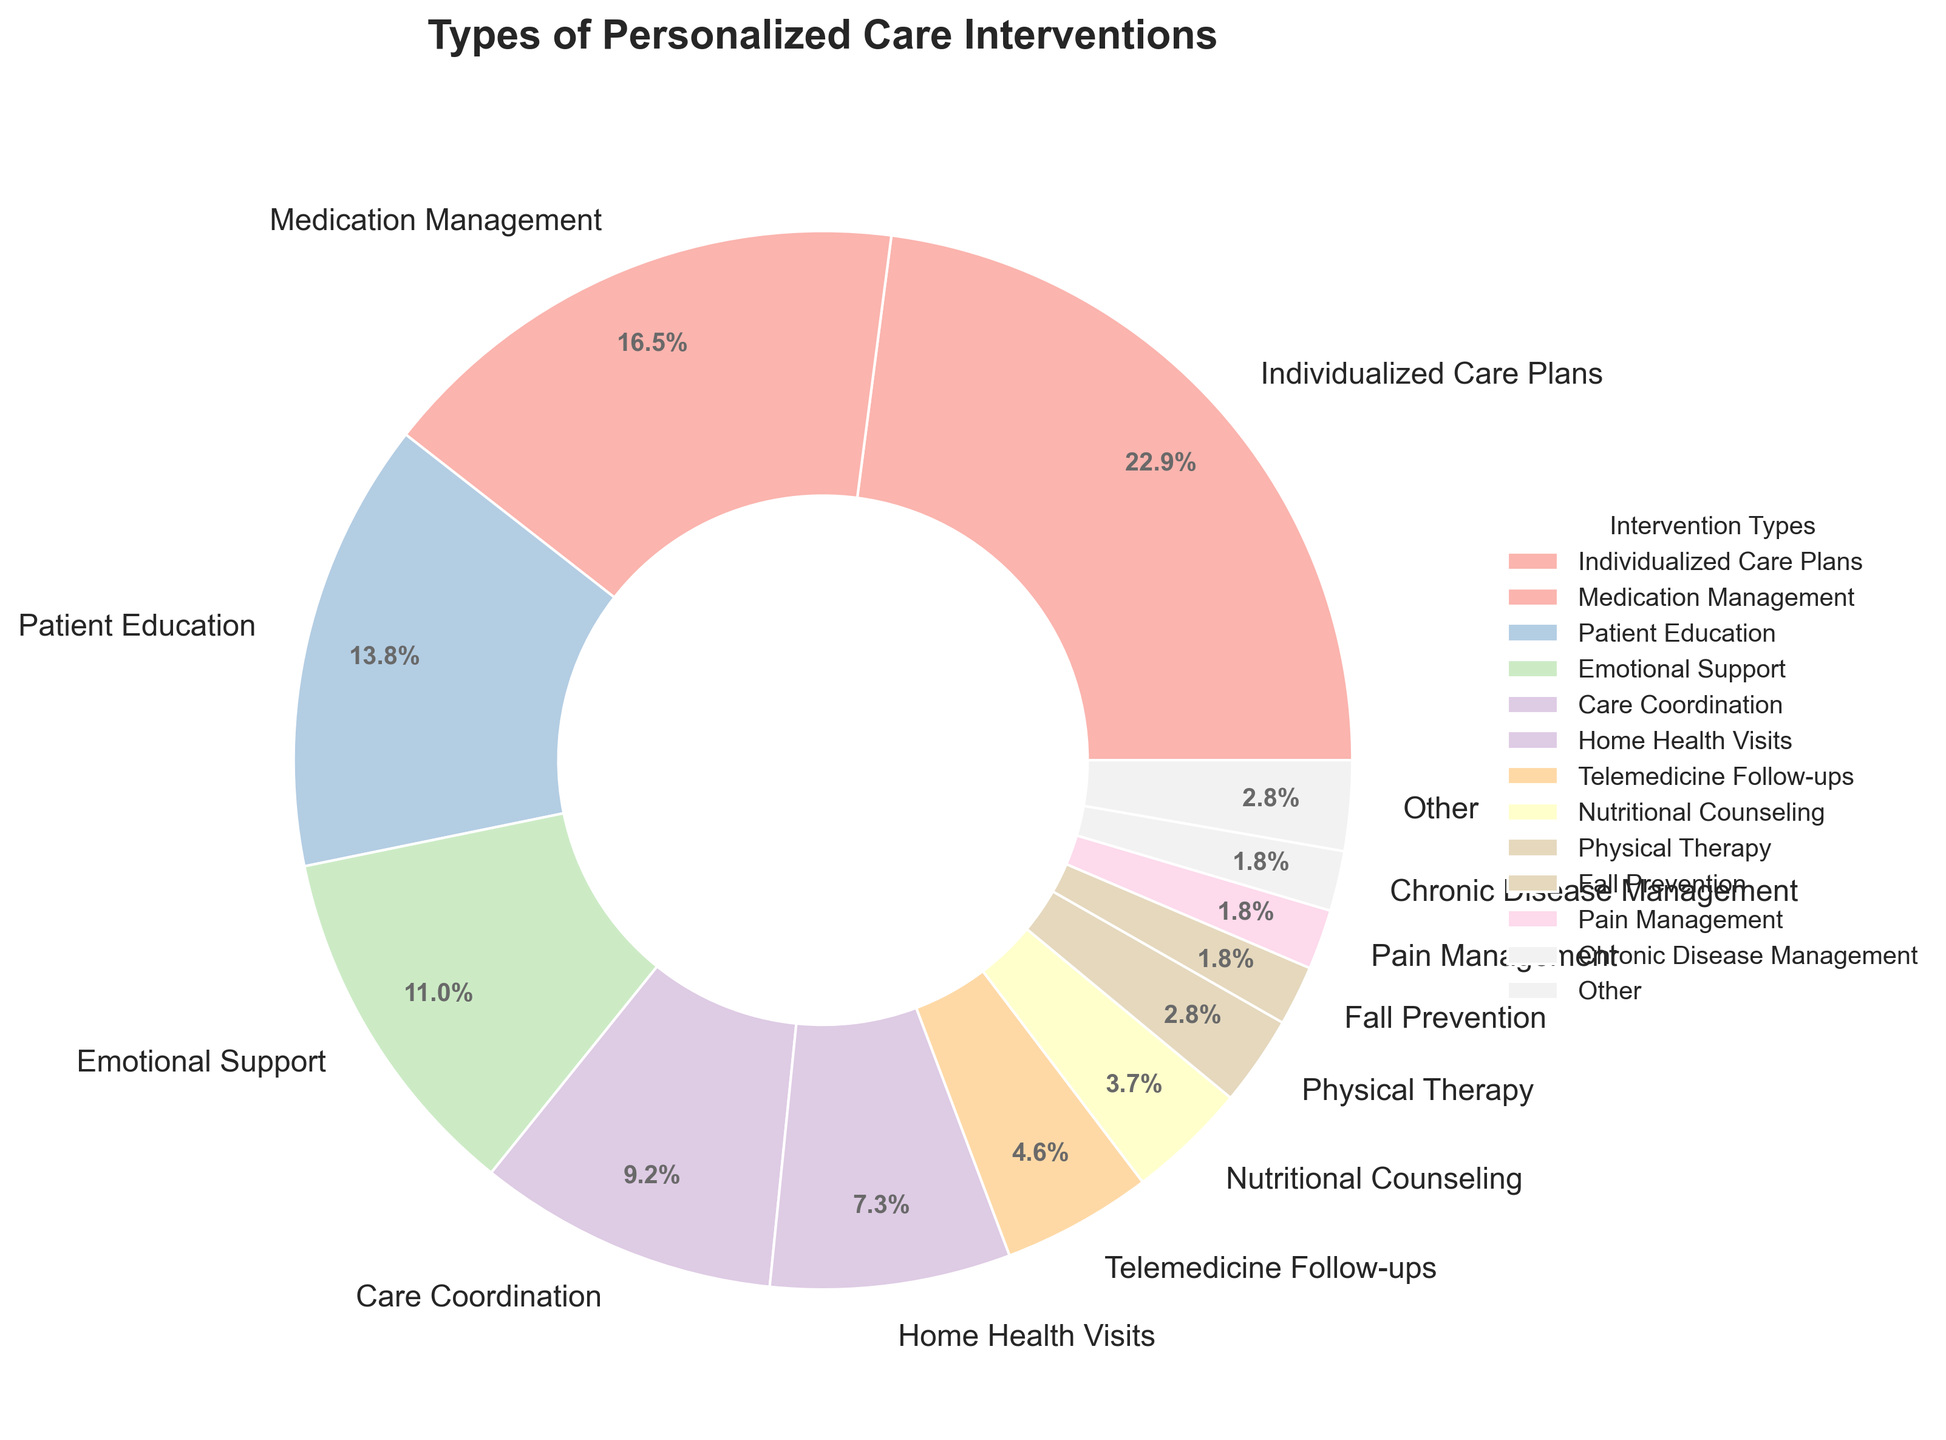What type of personalized care intervention is provided the most? The segment with the largest proportion is visually identifiable based on the chart's sizes and labels. Individualized Care Plans has the largest size representing 25%.
Answer: Individualized Care Plans Which two intervention types are both listed with less than 5%? Observing the size segments and labels in the chart, Telemedicine Follow-ups, and Nutritional Counseling are both listed with less than 5%. Their respective proportions are 5% and 4%.
Answer: Telemedicine Follow-ups and Nutritional Counseling What is the combined percentage of Emotional Support and Care Coordination interventions? The chart shows 12% for Emotional Support and 10% for Care Coordination. Adding these two values: 12% + 10% = 22%.
Answer: 22% Is Pain Management provided more or less than Cognitive Stimulation? By examining the labels and their corresponding sizes, Pain Management represents 2%, and Cognitive Stimulation represents 1%. Thus, Pain Management is provided more.
Answer: More Which intervention type falls in the 'Other' category and what is their total percentage? The slices representing less than 2% are aggregated into 'Other'. Visual identification shows that Fall Prevention, Pain Management, Chronic Disease Management, Cognitive Stimulation, Caregiver Support, and Wound Care are in 'Other'. Summing up their percentages: 2% + 2% + 2% + 1% + 1% + 1% = 9%.
Answer: Fall Prevention, Pain Management, Chronic Disease Management, Cognitive Stimulation, Caregiver Support, and Wound Care, 9% Compare the percentage of Medication Management to Home Health Visits. Which one is greater and by how much? Medication Management is 18%, and Home Health Visits is 8%. The difference between them: 18% - 8% = 10%.
Answer: Medication Management, 10% What is the visual attribute of the wedge representing Patient Education in the pie chart? Patient Education can be identified by its size corresponding to 15% in the pie chart. It is visually larger than most others, except for Individualized Care Plans, and has a specific color distinct from others in the palette used.
Answer: Larger-sized and unique color (Pastel) How many intervention types are provided with a percentage of 10% or more? Counting the segments with values of 10% or more, we see Individualized Care Plans (25%), Medication Management (18%), Patient Education (15%), Emotional Support (12%), and Care Coordination (10%). There are 5 such types.
Answer: 5 